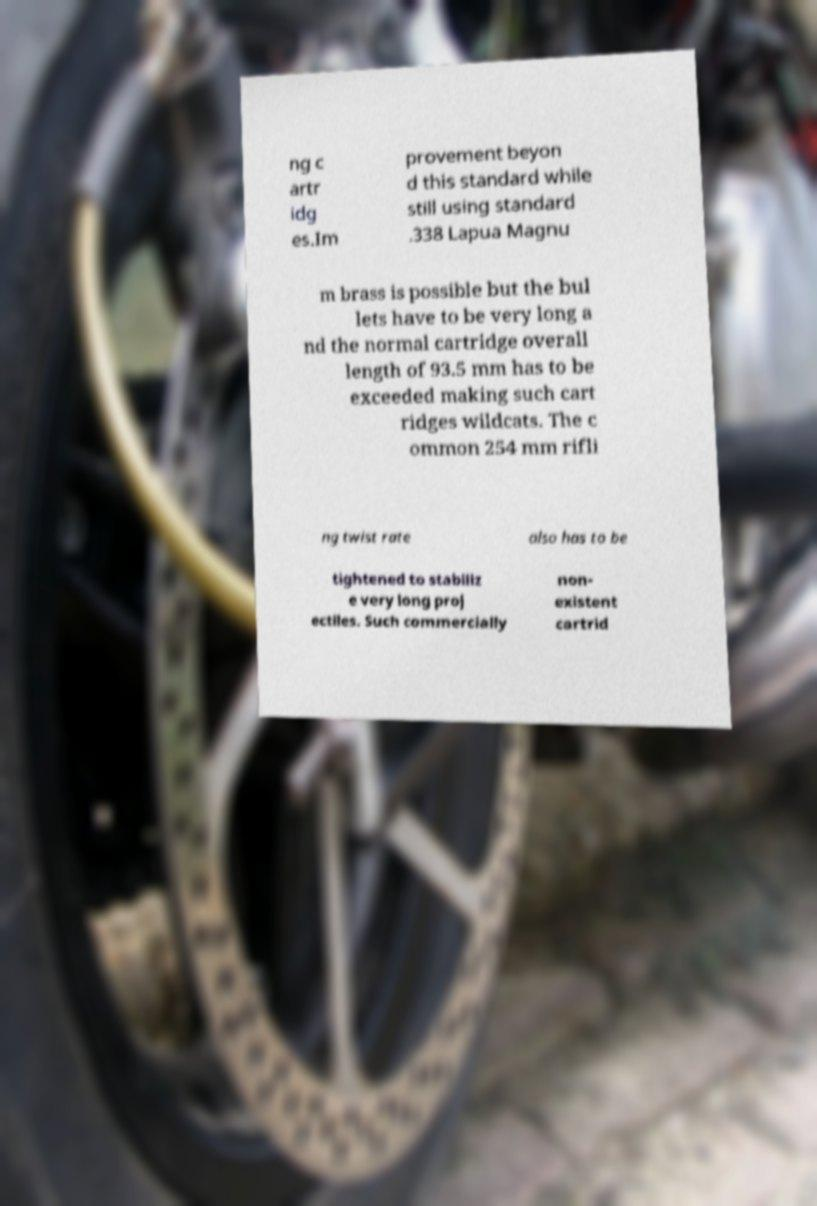What messages or text are displayed in this image? I need them in a readable, typed format. ng c artr idg es.Im provement beyon d this standard while still using standard .338 Lapua Magnu m brass is possible but the bul lets have to be very long a nd the normal cartridge overall length of 93.5 mm has to be exceeded making such cart ridges wildcats. The c ommon 254 mm rifli ng twist rate also has to be tightened to stabiliz e very long proj ectiles. Such commercially non- existent cartrid 